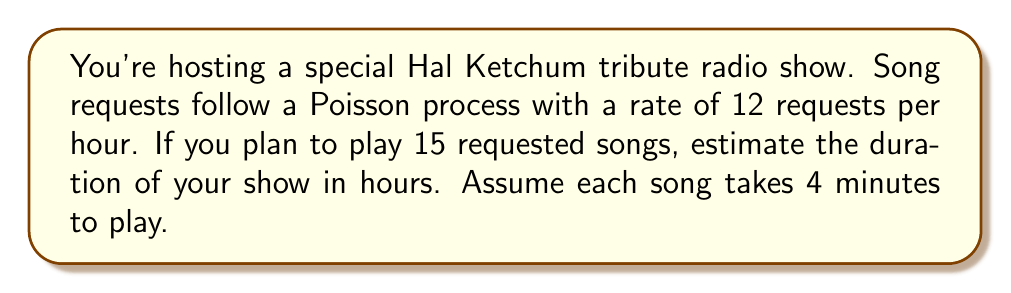Can you answer this question? Let's approach this step-by-step:

1) First, we need to understand what the Poisson process tells us:
   - Requests arrive at a rate of $\lambda = 12$ per hour

2) We want to know how long it takes for 15 requests to arrive. This is known as the Erlang distribution, which is the sum of $n$ independent exponentially distributed random variables.

3) For a Poisson process, the expected time between events (inter-arrival time) is $\frac{1}{\lambda}$

4) The expected time for $n$ events to occur is $n$ times the expected inter-arrival time:

   $$E[T] = n \cdot \frac{1}{\lambda} = \frac{n}{\lambda}$$

5) In this case:
   $$E[T] = \frac{15}{12} = 1.25 \text{ hours}$$

6) This is the time it takes to receive 15 requests. Now we need to add the time to play the songs:
   - Each song takes 4 minutes = $\frac{1}{15}$ hour
   - Total play time: $15 \cdot \frac{1}{15} = 1$ hour

7) Total estimated show duration:
   $$1.25 + 1 = 2.25 \text{ hours}$$
Answer: 2.25 hours 